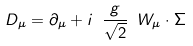<formula> <loc_0><loc_0><loc_500><loc_500>D _ { \mu } = \partial _ { \mu } + i \ \frac { g } { \sqrt { 2 } } \ W _ { \mu } \cdot \Sigma</formula> 